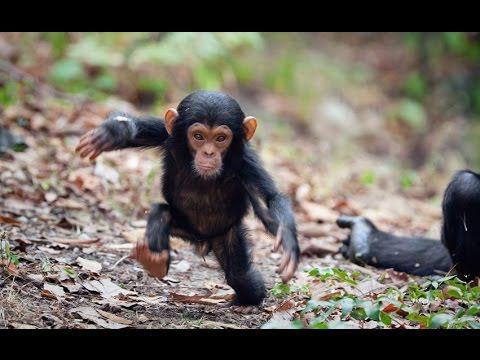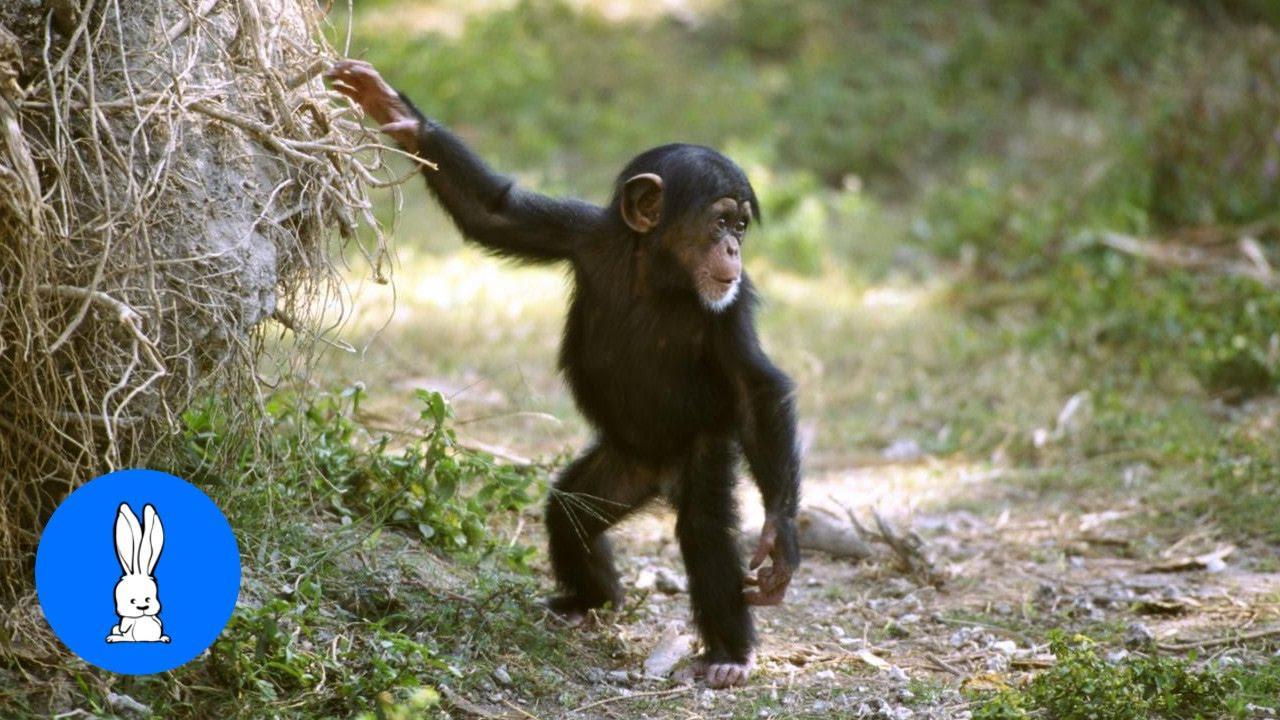The first image is the image on the left, the second image is the image on the right. Examine the images to the left and right. Is the description "A mother chimpanzee is holding a baby chimpanzee in her arms in one or the images." accurate? Answer yes or no. No. The first image is the image on the left, the second image is the image on the right. Assess this claim about the two images: "A image shows a sitting mother chimp holding a baby chimp.". Correct or not? Answer yes or no. No. 